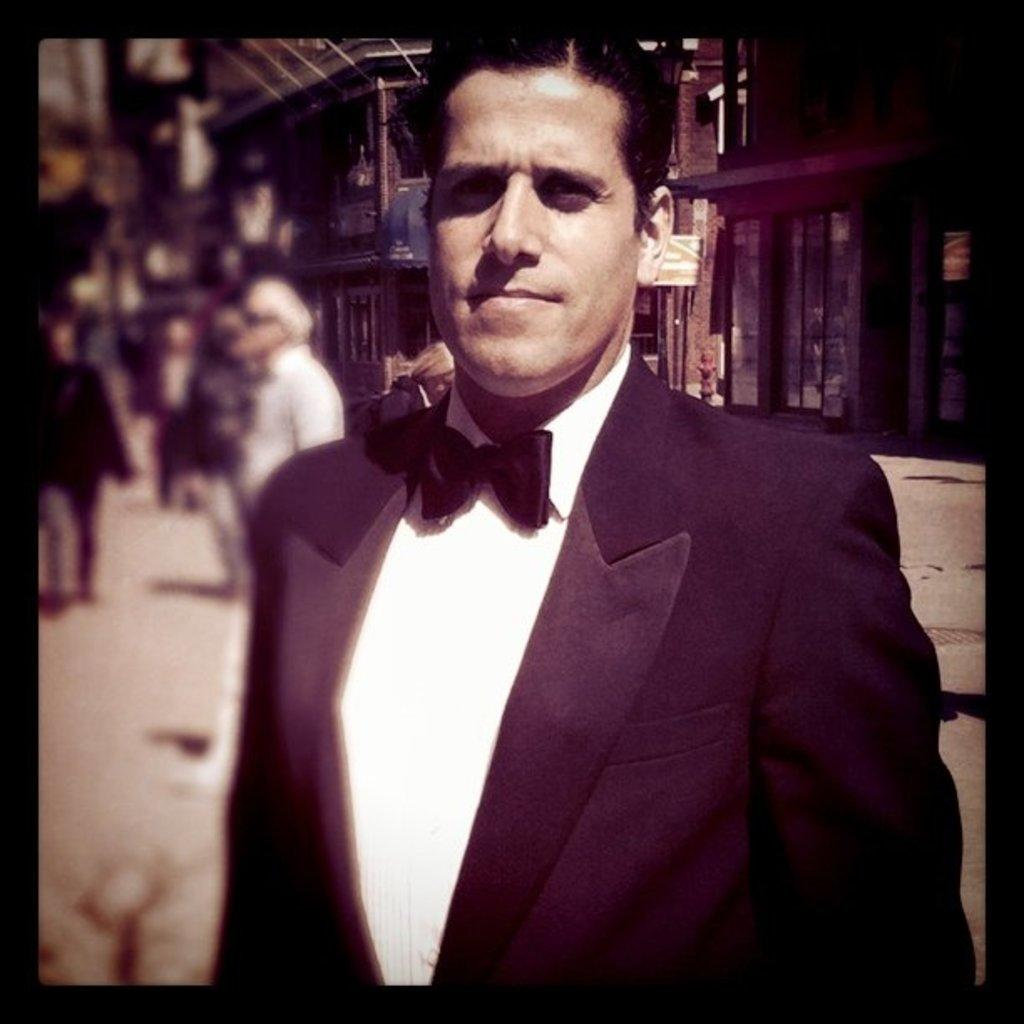Who is present in the image? There is a man in the image. What is the man wearing? The man is wearing a suit. What can be seen in the background of the image? There is a building in the background of the image. Are there any other people visible in the image? Yes, there are people standing on the street on the left side of the image. What type of servant can be seen attending to the man in the image? There is no servant present in the image; it only shows a man wearing a suit and people standing on the street. What selection of rakes is available for purchase in the image? There are no rakes visible in the image. 